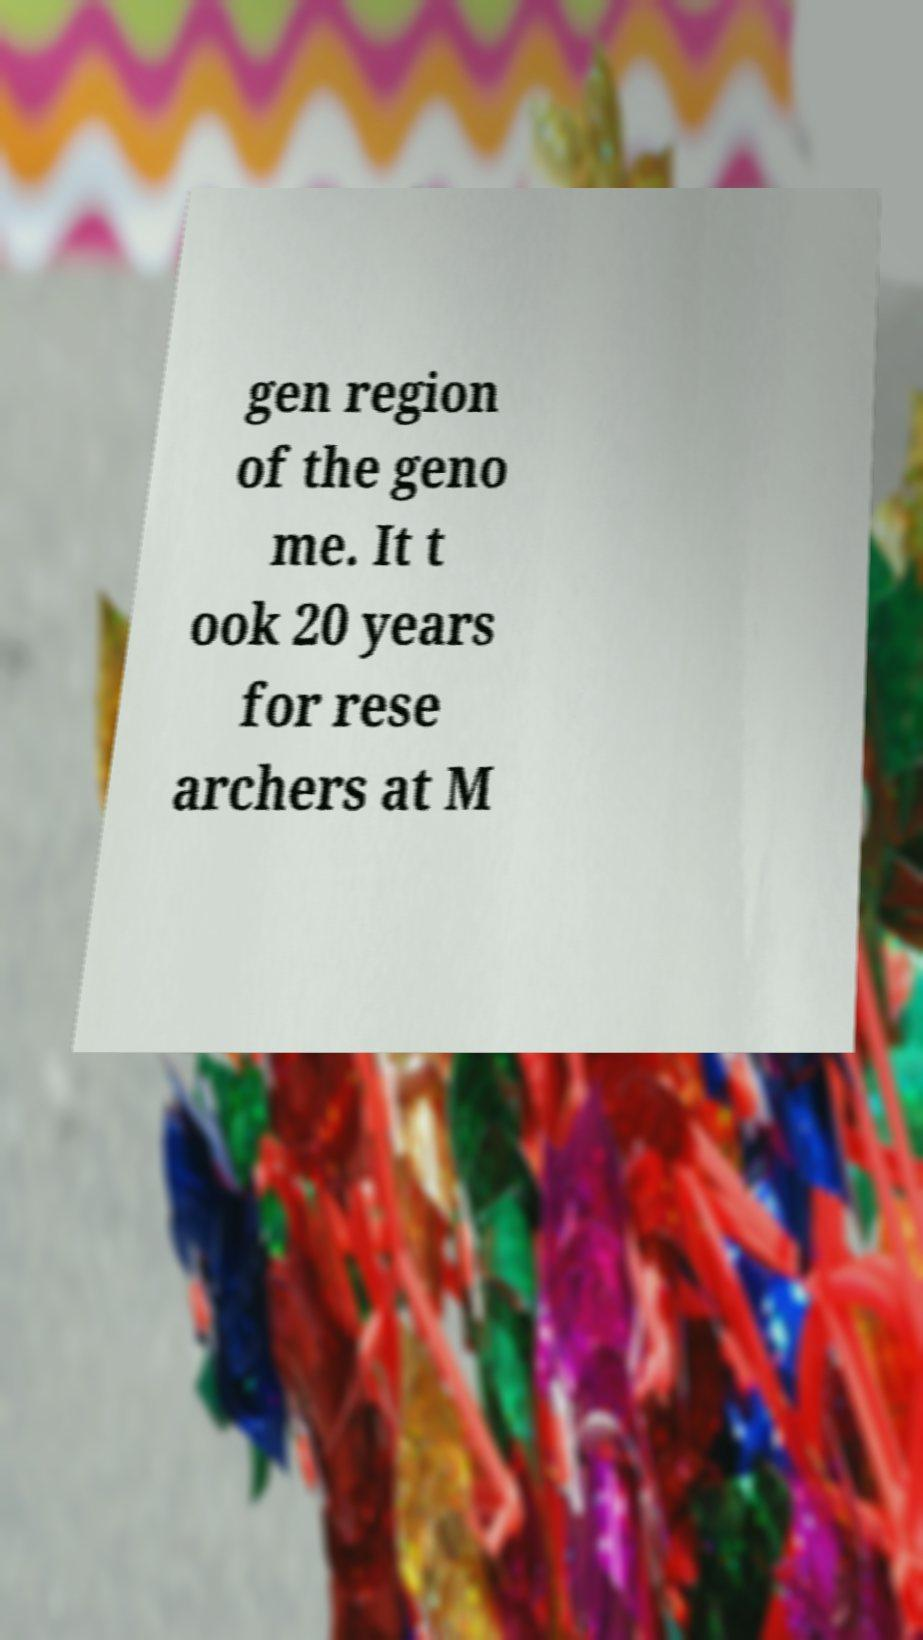Please read and relay the text visible in this image. What does it say? gen region of the geno me. It t ook 20 years for rese archers at M 